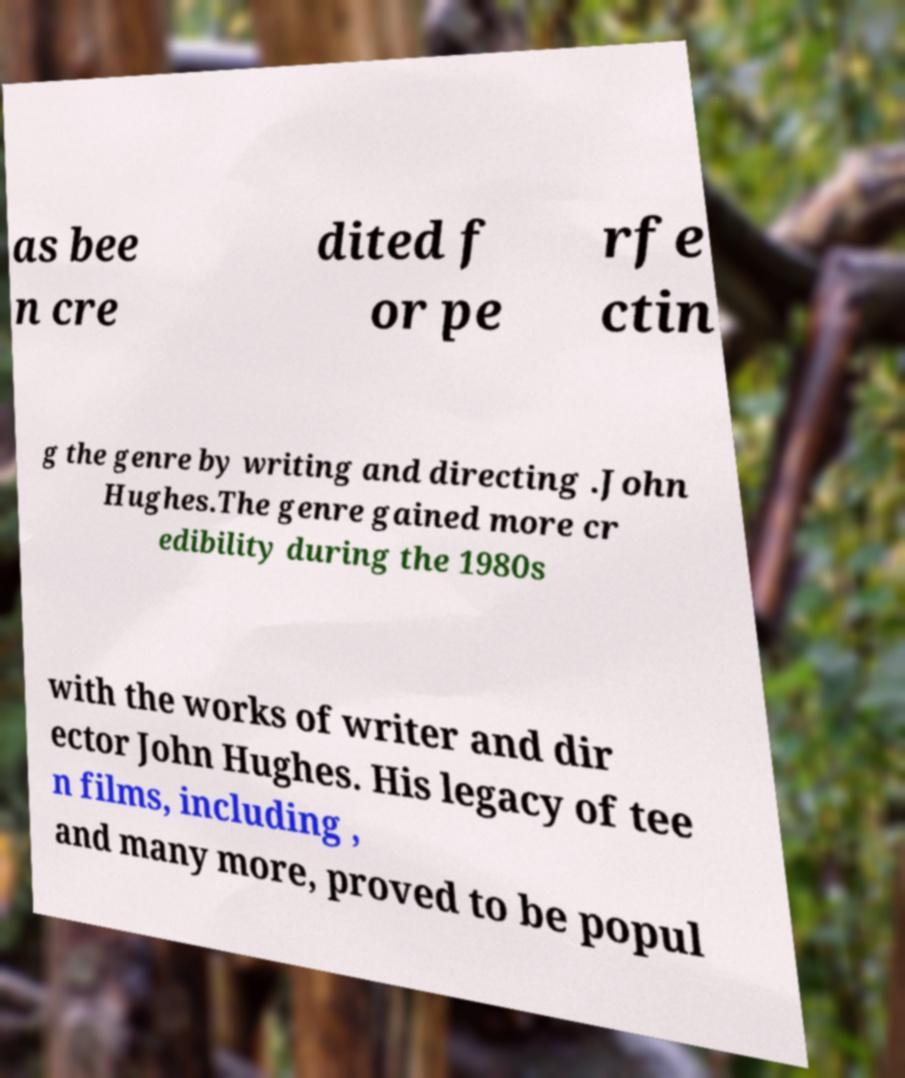I need the written content from this picture converted into text. Can you do that? as bee n cre dited f or pe rfe ctin g the genre by writing and directing .John Hughes.The genre gained more cr edibility during the 1980s with the works of writer and dir ector John Hughes. His legacy of tee n films, including , and many more, proved to be popul 